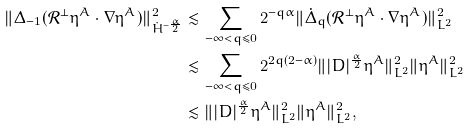<formula> <loc_0><loc_0><loc_500><loc_500>\| \Delta _ { - 1 } ( \mathcal { R } ^ { \perp } \eta ^ { A } \cdot \nabla \eta ^ { A } ) \| ^ { 2 } _ { \dot { H } ^ { - \frac { \alpha } { 2 } } } & \lesssim \sum _ { - \infty < q \leq 0 } 2 ^ { - q \alpha } \| \dot { \Delta } _ { q } ( \mathcal { R } ^ { \perp } \eta ^ { A } \cdot \nabla \eta ^ { A } ) \| _ { L ^ { 2 } } ^ { 2 } \\ & \lesssim \sum _ { - \infty < q \leq 0 } 2 ^ { 2 q ( 2 - \alpha ) } \| | D | ^ { \frac { \alpha } { 2 } } \eta ^ { A } \| ^ { 2 } _ { L ^ { 2 } } \| \eta ^ { A } \| ^ { 2 } _ { L ^ { 2 } } \\ & \lesssim \| | D | ^ { \frac { \alpha } { 2 } } \eta ^ { A } \| ^ { 2 } _ { L ^ { 2 } } \| \eta ^ { A } \| ^ { 2 } _ { L ^ { 2 } } ,</formula> 